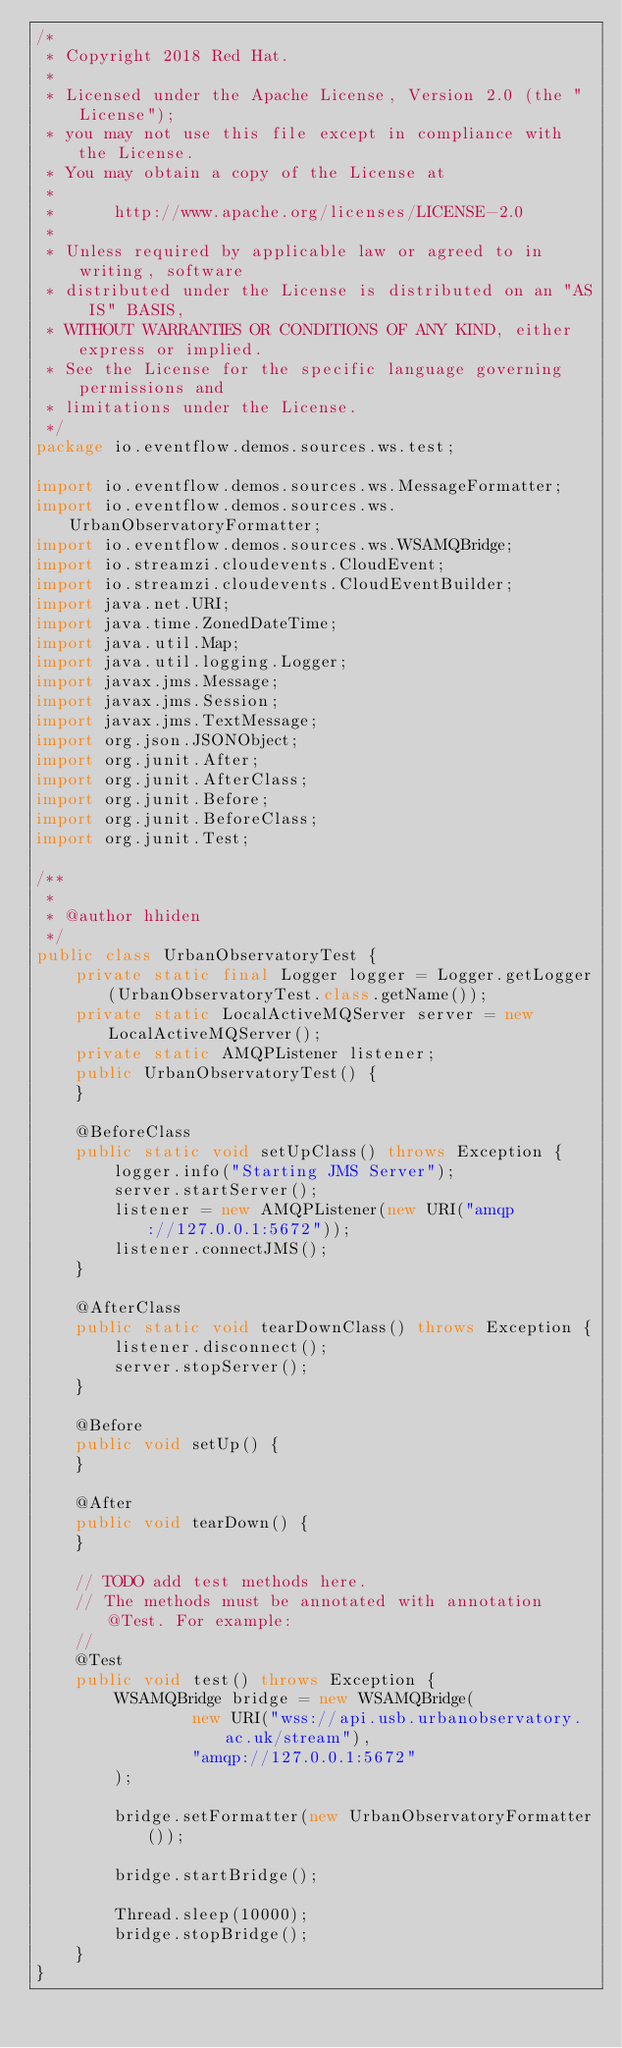<code> <loc_0><loc_0><loc_500><loc_500><_Java_>/*
 * Copyright 2018 Red Hat.
 *
 * Licensed under the Apache License, Version 2.0 (the "License");
 * you may not use this file except in compliance with the License.
 * You may obtain a copy of the License at
 *
 *      http://www.apache.org/licenses/LICENSE-2.0
 *
 * Unless required by applicable law or agreed to in writing, software
 * distributed under the License is distributed on an "AS IS" BASIS,
 * WITHOUT WARRANTIES OR CONDITIONS OF ANY KIND, either express or implied.
 * See the License for the specific language governing permissions and
 * limitations under the License.
 */
package io.eventflow.demos.sources.ws.test;

import io.eventflow.demos.sources.ws.MessageFormatter;
import io.eventflow.demos.sources.ws.UrbanObservatoryFormatter;
import io.eventflow.demos.sources.ws.WSAMQBridge;
import io.streamzi.cloudevents.CloudEvent;
import io.streamzi.cloudevents.CloudEventBuilder;
import java.net.URI;
import java.time.ZonedDateTime;
import java.util.Map;
import java.util.logging.Logger;
import javax.jms.Message;
import javax.jms.Session;
import javax.jms.TextMessage;
import org.json.JSONObject;
import org.junit.After;
import org.junit.AfterClass;
import org.junit.Before;
import org.junit.BeforeClass;
import org.junit.Test;

/**
 *
 * @author hhiden
 */
public class UrbanObservatoryTest {
    private static final Logger logger = Logger.getLogger(UrbanObservatoryTest.class.getName());
    private static LocalActiveMQServer server = new LocalActiveMQServer();
    private static AMQPListener listener;
    public UrbanObservatoryTest() {
    }
    
    @BeforeClass
    public static void setUpClass() throws Exception {
        logger.info("Starting JMS Server");
        server.startServer();
        listener = new AMQPListener(new URI("amqp://127.0.0.1:5672"));
        listener.connectJMS();
    }
    
    @AfterClass
    public static void tearDownClass() throws Exception {
        listener.disconnect();
        server.stopServer();
    }
    
    @Before
    public void setUp() {
    }
    
    @After
    public void tearDown() {
    }

    // TODO add test methods here.
    // The methods must be annotated with annotation @Test. For example:
    //
    @Test
    public void test() throws Exception {
        WSAMQBridge bridge = new WSAMQBridge(
                new URI("wss://api.usb.urbanobservatory.ac.uk/stream"),
                "amqp://127.0.0.1:5672"
        );
        
        bridge.setFormatter(new UrbanObservatoryFormatter());
        
        bridge.startBridge();
        
        Thread.sleep(10000);
        bridge.stopBridge();
    }
}
</code> 